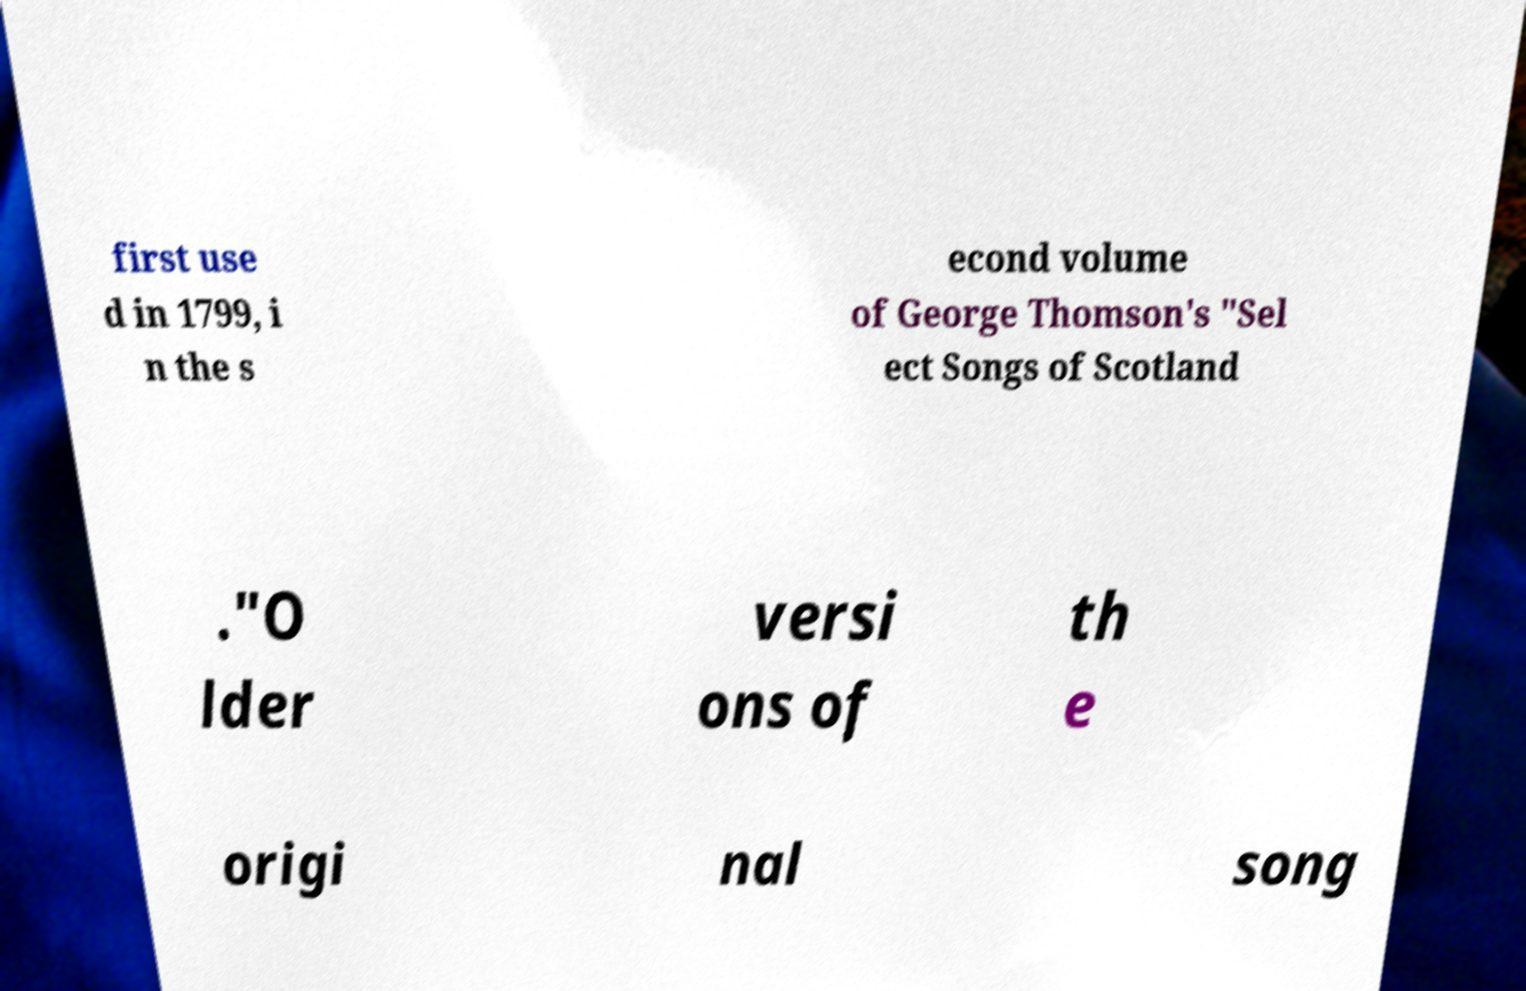There's text embedded in this image that I need extracted. Can you transcribe it verbatim? first use d in 1799, i n the s econd volume of George Thomson's "Sel ect Songs of Scotland ."O lder versi ons of th e origi nal song 